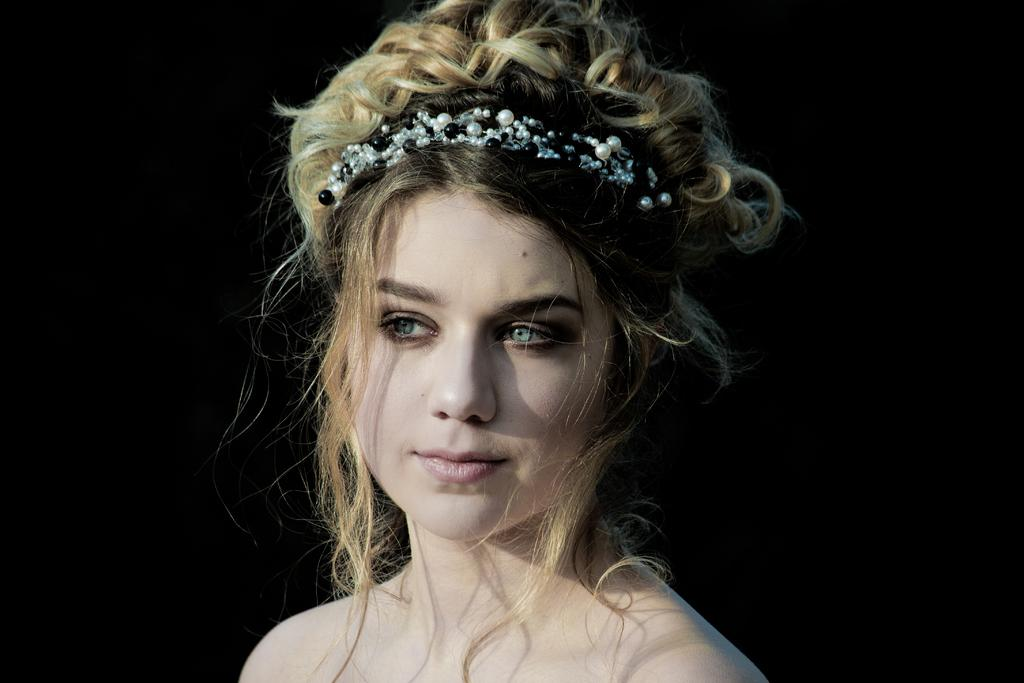What can be observed about the background of the image? The background of the image is completely dark. Can you describe the person in the image? There is a woman in the image. What is a noticeable feature of the woman's hair? The woman has brown hair. What accessory is the woman wearing in her hair? The woman is wearing a pearls hairband. How many stones can be seen in the woman's hair in the image? There are no stones visible in the woman's hair in the image. What type of muscle is the woman flexing in the image? There is no muscle flexing visible in the image; the woman is simply wearing a pearls hairband. 